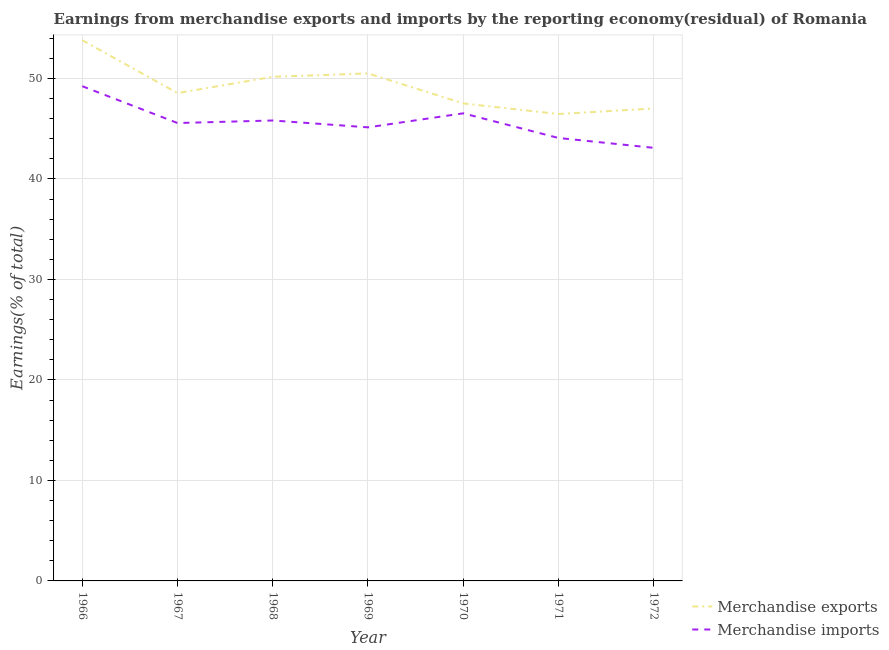How many different coloured lines are there?
Offer a very short reply. 2. What is the earnings from merchandise exports in 1970?
Your answer should be compact. 47.51. Across all years, what is the maximum earnings from merchandise imports?
Ensure brevity in your answer.  49.22. Across all years, what is the minimum earnings from merchandise exports?
Offer a very short reply. 46.46. In which year was the earnings from merchandise exports maximum?
Your answer should be compact. 1966. What is the total earnings from merchandise imports in the graph?
Provide a short and direct response. 319.42. What is the difference between the earnings from merchandise exports in 1966 and that in 1969?
Provide a succinct answer. 3.3. What is the difference between the earnings from merchandise imports in 1972 and the earnings from merchandise exports in 1971?
Make the answer very short. -3.36. What is the average earnings from merchandise imports per year?
Provide a short and direct response. 45.63. In the year 1966, what is the difference between the earnings from merchandise exports and earnings from merchandise imports?
Offer a very short reply. 4.57. What is the ratio of the earnings from merchandise exports in 1967 to that in 1970?
Provide a succinct answer. 1.02. Is the earnings from merchandise imports in 1966 less than that in 1968?
Provide a succinct answer. No. What is the difference between the highest and the second highest earnings from merchandise exports?
Keep it short and to the point. 3.3. What is the difference between the highest and the lowest earnings from merchandise imports?
Provide a short and direct response. 6.13. In how many years, is the earnings from merchandise imports greater than the average earnings from merchandise imports taken over all years?
Keep it short and to the point. 3. Is the earnings from merchandise exports strictly less than the earnings from merchandise imports over the years?
Offer a terse response. No. How many lines are there?
Offer a terse response. 2. What is the difference between two consecutive major ticks on the Y-axis?
Ensure brevity in your answer.  10. Are the values on the major ticks of Y-axis written in scientific E-notation?
Provide a short and direct response. No. What is the title of the graph?
Offer a terse response. Earnings from merchandise exports and imports by the reporting economy(residual) of Romania. What is the label or title of the X-axis?
Ensure brevity in your answer.  Year. What is the label or title of the Y-axis?
Ensure brevity in your answer.  Earnings(% of total). What is the Earnings(% of total) in Merchandise exports in 1966?
Your answer should be very brief. 53.8. What is the Earnings(% of total) of Merchandise imports in 1966?
Offer a terse response. 49.22. What is the Earnings(% of total) of Merchandise exports in 1967?
Ensure brevity in your answer.  48.54. What is the Earnings(% of total) of Merchandise imports in 1967?
Ensure brevity in your answer.  45.56. What is the Earnings(% of total) in Merchandise exports in 1968?
Make the answer very short. 50.16. What is the Earnings(% of total) in Merchandise imports in 1968?
Keep it short and to the point. 45.81. What is the Earnings(% of total) of Merchandise exports in 1969?
Provide a short and direct response. 50.5. What is the Earnings(% of total) in Merchandise imports in 1969?
Your response must be concise. 45.13. What is the Earnings(% of total) of Merchandise exports in 1970?
Provide a succinct answer. 47.51. What is the Earnings(% of total) of Merchandise imports in 1970?
Offer a terse response. 46.53. What is the Earnings(% of total) in Merchandise exports in 1971?
Your response must be concise. 46.46. What is the Earnings(% of total) of Merchandise imports in 1971?
Your answer should be compact. 44.07. What is the Earnings(% of total) of Merchandise exports in 1972?
Offer a very short reply. 47.01. What is the Earnings(% of total) in Merchandise imports in 1972?
Your answer should be compact. 43.09. Across all years, what is the maximum Earnings(% of total) of Merchandise exports?
Your answer should be compact. 53.8. Across all years, what is the maximum Earnings(% of total) in Merchandise imports?
Make the answer very short. 49.22. Across all years, what is the minimum Earnings(% of total) in Merchandise exports?
Your answer should be compact. 46.46. Across all years, what is the minimum Earnings(% of total) in Merchandise imports?
Give a very brief answer. 43.09. What is the total Earnings(% of total) in Merchandise exports in the graph?
Give a very brief answer. 343.97. What is the total Earnings(% of total) in Merchandise imports in the graph?
Ensure brevity in your answer.  319.42. What is the difference between the Earnings(% of total) in Merchandise exports in 1966 and that in 1967?
Ensure brevity in your answer.  5.26. What is the difference between the Earnings(% of total) of Merchandise imports in 1966 and that in 1967?
Keep it short and to the point. 3.66. What is the difference between the Earnings(% of total) of Merchandise exports in 1966 and that in 1968?
Offer a terse response. 3.64. What is the difference between the Earnings(% of total) in Merchandise imports in 1966 and that in 1968?
Your response must be concise. 3.41. What is the difference between the Earnings(% of total) of Merchandise exports in 1966 and that in 1969?
Provide a succinct answer. 3.3. What is the difference between the Earnings(% of total) in Merchandise imports in 1966 and that in 1969?
Offer a terse response. 4.09. What is the difference between the Earnings(% of total) of Merchandise exports in 1966 and that in 1970?
Your answer should be very brief. 6.29. What is the difference between the Earnings(% of total) of Merchandise imports in 1966 and that in 1970?
Make the answer very short. 2.7. What is the difference between the Earnings(% of total) in Merchandise exports in 1966 and that in 1971?
Provide a short and direct response. 7.34. What is the difference between the Earnings(% of total) of Merchandise imports in 1966 and that in 1971?
Make the answer very short. 5.15. What is the difference between the Earnings(% of total) in Merchandise exports in 1966 and that in 1972?
Offer a terse response. 6.79. What is the difference between the Earnings(% of total) of Merchandise imports in 1966 and that in 1972?
Ensure brevity in your answer.  6.13. What is the difference between the Earnings(% of total) in Merchandise exports in 1967 and that in 1968?
Offer a terse response. -1.62. What is the difference between the Earnings(% of total) of Merchandise imports in 1967 and that in 1968?
Give a very brief answer. -0.25. What is the difference between the Earnings(% of total) of Merchandise exports in 1967 and that in 1969?
Offer a terse response. -1.96. What is the difference between the Earnings(% of total) in Merchandise imports in 1967 and that in 1969?
Offer a very short reply. 0.43. What is the difference between the Earnings(% of total) of Merchandise exports in 1967 and that in 1970?
Make the answer very short. 1.03. What is the difference between the Earnings(% of total) of Merchandise imports in 1967 and that in 1970?
Offer a very short reply. -0.97. What is the difference between the Earnings(% of total) of Merchandise exports in 1967 and that in 1971?
Your answer should be compact. 2.08. What is the difference between the Earnings(% of total) in Merchandise imports in 1967 and that in 1971?
Offer a terse response. 1.49. What is the difference between the Earnings(% of total) in Merchandise exports in 1967 and that in 1972?
Keep it short and to the point. 1.53. What is the difference between the Earnings(% of total) of Merchandise imports in 1967 and that in 1972?
Offer a terse response. 2.47. What is the difference between the Earnings(% of total) in Merchandise exports in 1968 and that in 1969?
Ensure brevity in your answer.  -0.34. What is the difference between the Earnings(% of total) in Merchandise imports in 1968 and that in 1969?
Provide a short and direct response. 0.68. What is the difference between the Earnings(% of total) of Merchandise exports in 1968 and that in 1970?
Offer a terse response. 2.65. What is the difference between the Earnings(% of total) in Merchandise imports in 1968 and that in 1970?
Offer a terse response. -0.71. What is the difference between the Earnings(% of total) of Merchandise exports in 1968 and that in 1971?
Keep it short and to the point. 3.7. What is the difference between the Earnings(% of total) of Merchandise imports in 1968 and that in 1971?
Give a very brief answer. 1.74. What is the difference between the Earnings(% of total) in Merchandise exports in 1968 and that in 1972?
Your answer should be very brief. 3.15. What is the difference between the Earnings(% of total) in Merchandise imports in 1968 and that in 1972?
Offer a very short reply. 2.72. What is the difference between the Earnings(% of total) in Merchandise exports in 1969 and that in 1970?
Your answer should be very brief. 2.99. What is the difference between the Earnings(% of total) of Merchandise imports in 1969 and that in 1970?
Your response must be concise. -1.39. What is the difference between the Earnings(% of total) in Merchandise exports in 1969 and that in 1971?
Offer a very short reply. 4.04. What is the difference between the Earnings(% of total) in Merchandise imports in 1969 and that in 1971?
Keep it short and to the point. 1.06. What is the difference between the Earnings(% of total) of Merchandise exports in 1969 and that in 1972?
Provide a succinct answer. 3.49. What is the difference between the Earnings(% of total) of Merchandise imports in 1969 and that in 1972?
Your answer should be compact. 2.04. What is the difference between the Earnings(% of total) in Merchandise exports in 1970 and that in 1971?
Offer a very short reply. 1.05. What is the difference between the Earnings(% of total) of Merchandise imports in 1970 and that in 1971?
Keep it short and to the point. 2.45. What is the difference between the Earnings(% of total) in Merchandise exports in 1970 and that in 1972?
Offer a terse response. 0.5. What is the difference between the Earnings(% of total) in Merchandise imports in 1970 and that in 1972?
Your answer should be compact. 3.43. What is the difference between the Earnings(% of total) in Merchandise exports in 1971 and that in 1972?
Your answer should be compact. -0.55. What is the difference between the Earnings(% of total) in Merchandise exports in 1966 and the Earnings(% of total) in Merchandise imports in 1967?
Offer a very short reply. 8.24. What is the difference between the Earnings(% of total) of Merchandise exports in 1966 and the Earnings(% of total) of Merchandise imports in 1968?
Your answer should be compact. 7.98. What is the difference between the Earnings(% of total) of Merchandise exports in 1966 and the Earnings(% of total) of Merchandise imports in 1969?
Your answer should be compact. 8.67. What is the difference between the Earnings(% of total) in Merchandise exports in 1966 and the Earnings(% of total) in Merchandise imports in 1970?
Provide a short and direct response. 7.27. What is the difference between the Earnings(% of total) in Merchandise exports in 1966 and the Earnings(% of total) in Merchandise imports in 1971?
Keep it short and to the point. 9.72. What is the difference between the Earnings(% of total) of Merchandise exports in 1966 and the Earnings(% of total) of Merchandise imports in 1972?
Ensure brevity in your answer.  10.7. What is the difference between the Earnings(% of total) of Merchandise exports in 1967 and the Earnings(% of total) of Merchandise imports in 1968?
Your answer should be compact. 2.73. What is the difference between the Earnings(% of total) of Merchandise exports in 1967 and the Earnings(% of total) of Merchandise imports in 1969?
Provide a short and direct response. 3.41. What is the difference between the Earnings(% of total) in Merchandise exports in 1967 and the Earnings(% of total) in Merchandise imports in 1970?
Offer a terse response. 2.01. What is the difference between the Earnings(% of total) of Merchandise exports in 1967 and the Earnings(% of total) of Merchandise imports in 1971?
Offer a terse response. 4.47. What is the difference between the Earnings(% of total) in Merchandise exports in 1967 and the Earnings(% of total) in Merchandise imports in 1972?
Offer a very short reply. 5.45. What is the difference between the Earnings(% of total) of Merchandise exports in 1968 and the Earnings(% of total) of Merchandise imports in 1969?
Keep it short and to the point. 5.03. What is the difference between the Earnings(% of total) of Merchandise exports in 1968 and the Earnings(% of total) of Merchandise imports in 1970?
Your answer should be compact. 3.63. What is the difference between the Earnings(% of total) of Merchandise exports in 1968 and the Earnings(% of total) of Merchandise imports in 1971?
Your answer should be compact. 6.09. What is the difference between the Earnings(% of total) in Merchandise exports in 1968 and the Earnings(% of total) in Merchandise imports in 1972?
Provide a succinct answer. 7.07. What is the difference between the Earnings(% of total) of Merchandise exports in 1969 and the Earnings(% of total) of Merchandise imports in 1970?
Your answer should be compact. 3.97. What is the difference between the Earnings(% of total) of Merchandise exports in 1969 and the Earnings(% of total) of Merchandise imports in 1971?
Ensure brevity in your answer.  6.42. What is the difference between the Earnings(% of total) in Merchandise exports in 1969 and the Earnings(% of total) in Merchandise imports in 1972?
Offer a very short reply. 7.4. What is the difference between the Earnings(% of total) in Merchandise exports in 1970 and the Earnings(% of total) in Merchandise imports in 1971?
Offer a terse response. 3.44. What is the difference between the Earnings(% of total) of Merchandise exports in 1970 and the Earnings(% of total) of Merchandise imports in 1972?
Keep it short and to the point. 4.42. What is the difference between the Earnings(% of total) in Merchandise exports in 1971 and the Earnings(% of total) in Merchandise imports in 1972?
Your answer should be very brief. 3.36. What is the average Earnings(% of total) of Merchandise exports per year?
Keep it short and to the point. 49.14. What is the average Earnings(% of total) of Merchandise imports per year?
Your answer should be compact. 45.63. In the year 1966, what is the difference between the Earnings(% of total) in Merchandise exports and Earnings(% of total) in Merchandise imports?
Provide a short and direct response. 4.57. In the year 1967, what is the difference between the Earnings(% of total) of Merchandise exports and Earnings(% of total) of Merchandise imports?
Offer a terse response. 2.98. In the year 1968, what is the difference between the Earnings(% of total) in Merchandise exports and Earnings(% of total) in Merchandise imports?
Make the answer very short. 4.35. In the year 1969, what is the difference between the Earnings(% of total) in Merchandise exports and Earnings(% of total) in Merchandise imports?
Your response must be concise. 5.37. In the year 1970, what is the difference between the Earnings(% of total) in Merchandise exports and Earnings(% of total) in Merchandise imports?
Ensure brevity in your answer.  0.99. In the year 1971, what is the difference between the Earnings(% of total) of Merchandise exports and Earnings(% of total) of Merchandise imports?
Keep it short and to the point. 2.38. In the year 1972, what is the difference between the Earnings(% of total) of Merchandise exports and Earnings(% of total) of Merchandise imports?
Make the answer very short. 3.91. What is the ratio of the Earnings(% of total) in Merchandise exports in 1966 to that in 1967?
Offer a very short reply. 1.11. What is the ratio of the Earnings(% of total) in Merchandise imports in 1966 to that in 1967?
Give a very brief answer. 1.08. What is the ratio of the Earnings(% of total) in Merchandise exports in 1966 to that in 1968?
Make the answer very short. 1.07. What is the ratio of the Earnings(% of total) in Merchandise imports in 1966 to that in 1968?
Make the answer very short. 1.07. What is the ratio of the Earnings(% of total) in Merchandise exports in 1966 to that in 1969?
Provide a short and direct response. 1.07. What is the ratio of the Earnings(% of total) in Merchandise imports in 1966 to that in 1969?
Your answer should be compact. 1.09. What is the ratio of the Earnings(% of total) of Merchandise exports in 1966 to that in 1970?
Your answer should be very brief. 1.13. What is the ratio of the Earnings(% of total) of Merchandise imports in 1966 to that in 1970?
Keep it short and to the point. 1.06. What is the ratio of the Earnings(% of total) of Merchandise exports in 1966 to that in 1971?
Provide a short and direct response. 1.16. What is the ratio of the Earnings(% of total) in Merchandise imports in 1966 to that in 1971?
Give a very brief answer. 1.12. What is the ratio of the Earnings(% of total) of Merchandise exports in 1966 to that in 1972?
Keep it short and to the point. 1.14. What is the ratio of the Earnings(% of total) in Merchandise imports in 1966 to that in 1972?
Make the answer very short. 1.14. What is the ratio of the Earnings(% of total) in Merchandise imports in 1967 to that in 1968?
Provide a short and direct response. 0.99. What is the ratio of the Earnings(% of total) in Merchandise exports in 1967 to that in 1969?
Provide a succinct answer. 0.96. What is the ratio of the Earnings(% of total) of Merchandise imports in 1967 to that in 1969?
Offer a terse response. 1.01. What is the ratio of the Earnings(% of total) in Merchandise exports in 1967 to that in 1970?
Provide a short and direct response. 1.02. What is the ratio of the Earnings(% of total) in Merchandise imports in 1967 to that in 1970?
Provide a succinct answer. 0.98. What is the ratio of the Earnings(% of total) in Merchandise exports in 1967 to that in 1971?
Provide a succinct answer. 1.04. What is the ratio of the Earnings(% of total) in Merchandise imports in 1967 to that in 1971?
Offer a very short reply. 1.03. What is the ratio of the Earnings(% of total) in Merchandise exports in 1967 to that in 1972?
Give a very brief answer. 1.03. What is the ratio of the Earnings(% of total) of Merchandise imports in 1967 to that in 1972?
Your answer should be very brief. 1.06. What is the ratio of the Earnings(% of total) in Merchandise imports in 1968 to that in 1969?
Offer a terse response. 1.02. What is the ratio of the Earnings(% of total) in Merchandise exports in 1968 to that in 1970?
Provide a succinct answer. 1.06. What is the ratio of the Earnings(% of total) in Merchandise imports in 1968 to that in 1970?
Give a very brief answer. 0.98. What is the ratio of the Earnings(% of total) of Merchandise exports in 1968 to that in 1971?
Your response must be concise. 1.08. What is the ratio of the Earnings(% of total) in Merchandise imports in 1968 to that in 1971?
Ensure brevity in your answer.  1.04. What is the ratio of the Earnings(% of total) in Merchandise exports in 1968 to that in 1972?
Offer a terse response. 1.07. What is the ratio of the Earnings(% of total) in Merchandise imports in 1968 to that in 1972?
Make the answer very short. 1.06. What is the ratio of the Earnings(% of total) of Merchandise exports in 1969 to that in 1970?
Provide a succinct answer. 1.06. What is the ratio of the Earnings(% of total) of Merchandise imports in 1969 to that in 1970?
Your answer should be compact. 0.97. What is the ratio of the Earnings(% of total) of Merchandise exports in 1969 to that in 1971?
Provide a short and direct response. 1.09. What is the ratio of the Earnings(% of total) in Merchandise exports in 1969 to that in 1972?
Your answer should be compact. 1.07. What is the ratio of the Earnings(% of total) of Merchandise imports in 1969 to that in 1972?
Your response must be concise. 1.05. What is the ratio of the Earnings(% of total) in Merchandise exports in 1970 to that in 1971?
Make the answer very short. 1.02. What is the ratio of the Earnings(% of total) of Merchandise imports in 1970 to that in 1971?
Your answer should be compact. 1.06. What is the ratio of the Earnings(% of total) of Merchandise exports in 1970 to that in 1972?
Keep it short and to the point. 1.01. What is the ratio of the Earnings(% of total) of Merchandise imports in 1970 to that in 1972?
Provide a succinct answer. 1.08. What is the ratio of the Earnings(% of total) of Merchandise exports in 1971 to that in 1972?
Give a very brief answer. 0.99. What is the ratio of the Earnings(% of total) in Merchandise imports in 1971 to that in 1972?
Your answer should be very brief. 1.02. What is the difference between the highest and the second highest Earnings(% of total) of Merchandise exports?
Offer a terse response. 3.3. What is the difference between the highest and the second highest Earnings(% of total) of Merchandise imports?
Provide a short and direct response. 2.7. What is the difference between the highest and the lowest Earnings(% of total) of Merchandise exports?
Keep it short and to the point. 7.34. What is the difference between the highest and the lowest Earnings(% of total) in Merchandise imports?
Keep it short and to the point. 6.13. 